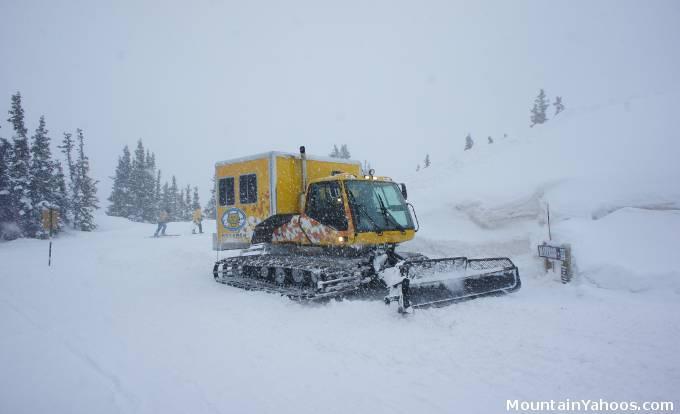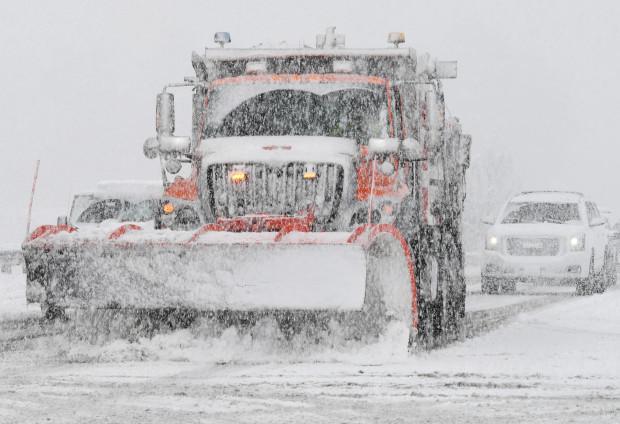The first image is the image on the left, the second image is the image on the right. For the images displayed, is the sentence "The yellow truck is pushing the snow in the image on the left." factually correct? Answer yes or no. Yes. The first image is the image on the left, the second image is the image on the right. Evaluate the accuracy of this statement regarding the images: "An image shows a truck with wheels instead of tank tracks heading rightward pushing snow, and the truck bed is bright yellow.". Is it true? Answer yes or no. No. 